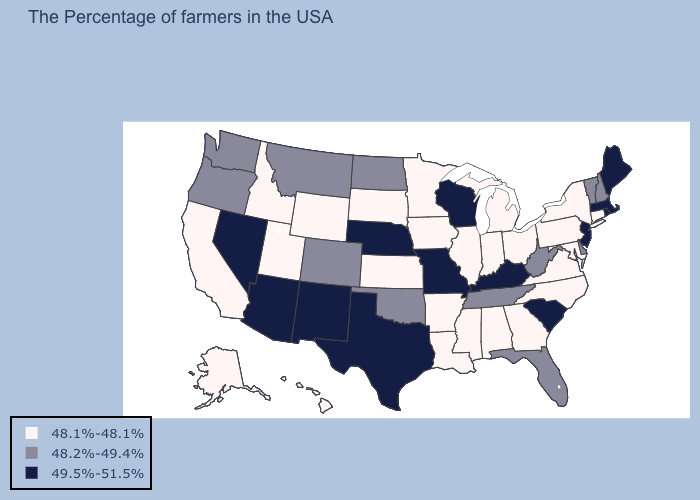Does South Dakota have the lowest value in the USA?
Give a very brief answer. Yes. Does North Dakota have the same value as Vermont?
Short answer required. Yes. What is the value of Oklahoma?
Give a very brief answer. 48.2%-49.4%. Which states have the lowest value in the Northeast?
Keep it brief. Connecticut, New York, Pennsylvania. Does Arkansas have the lowest value in the South?
Short answer required. Yes. How many symbols are there in the legend?
Short answer required. 3. What is the value of Connecticut?
Give a very brief answer. 48.1%-48.1%. Does the map have missing data?
Write a very short answer. No. Does Montana have the highest value in the USA?
Concise answer only. No. What is the value of South Dakota?
Answer briefly. 48.1%-48.1%. Does New Hampshire have the lowest value in the Northeast?
Concise answer only. No. Name the states that have a value in the range 48.2%-49.4%?
Concise answer only. New Hampshire, Vermont, Delaware, West Virginia, Florida, Tennessee, Oklahoma, North Dakota, Colorado, Montana, Washington, Oregon. Name the states that have a value in the range 48.1%-48.1%?
Write a very short answer. Connecticut, New York, Maryland, Pennsylvania, Virginia, North Carolina, Ohio, Georgia, Michigan, Indiana, Alabama, Illinois, Mississippi, Louisiana, Arkansas, Minnesota, Iowa, Kansas, South Dakota, Wyoming, Utah, Idaho, California, Alaska, Hawaii. Does West Virginia have the highest value in the South?
Concise answer only. No. Which states have the highest value in the USA?
Write a very short answer. Maine, Massachusetts, Rhode Island, New Jersey, South Carolina, Kentucky, Wisconsin, Missouri, Nebraska, Texas, New Mexico, Arizona, Nevada. 